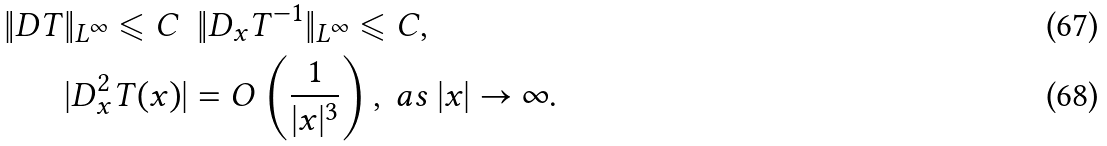<formula> <loc_0><loc_0><loc_500><loc_500>\| D T \| _ { L ^ { \infty } } \leqslant C \ & \ \| D _ { x } T ^ { - 1 } \| _ { L ^ { \infty } } \leqslant C , \\ | D _ { x } ^ { 2 } T ( x ) | & = { O } \left ( \frac { 1 } { | x | ^ { 3 } } \right ) , \ a s \ | x | \rightarrow \infty .</formula> 